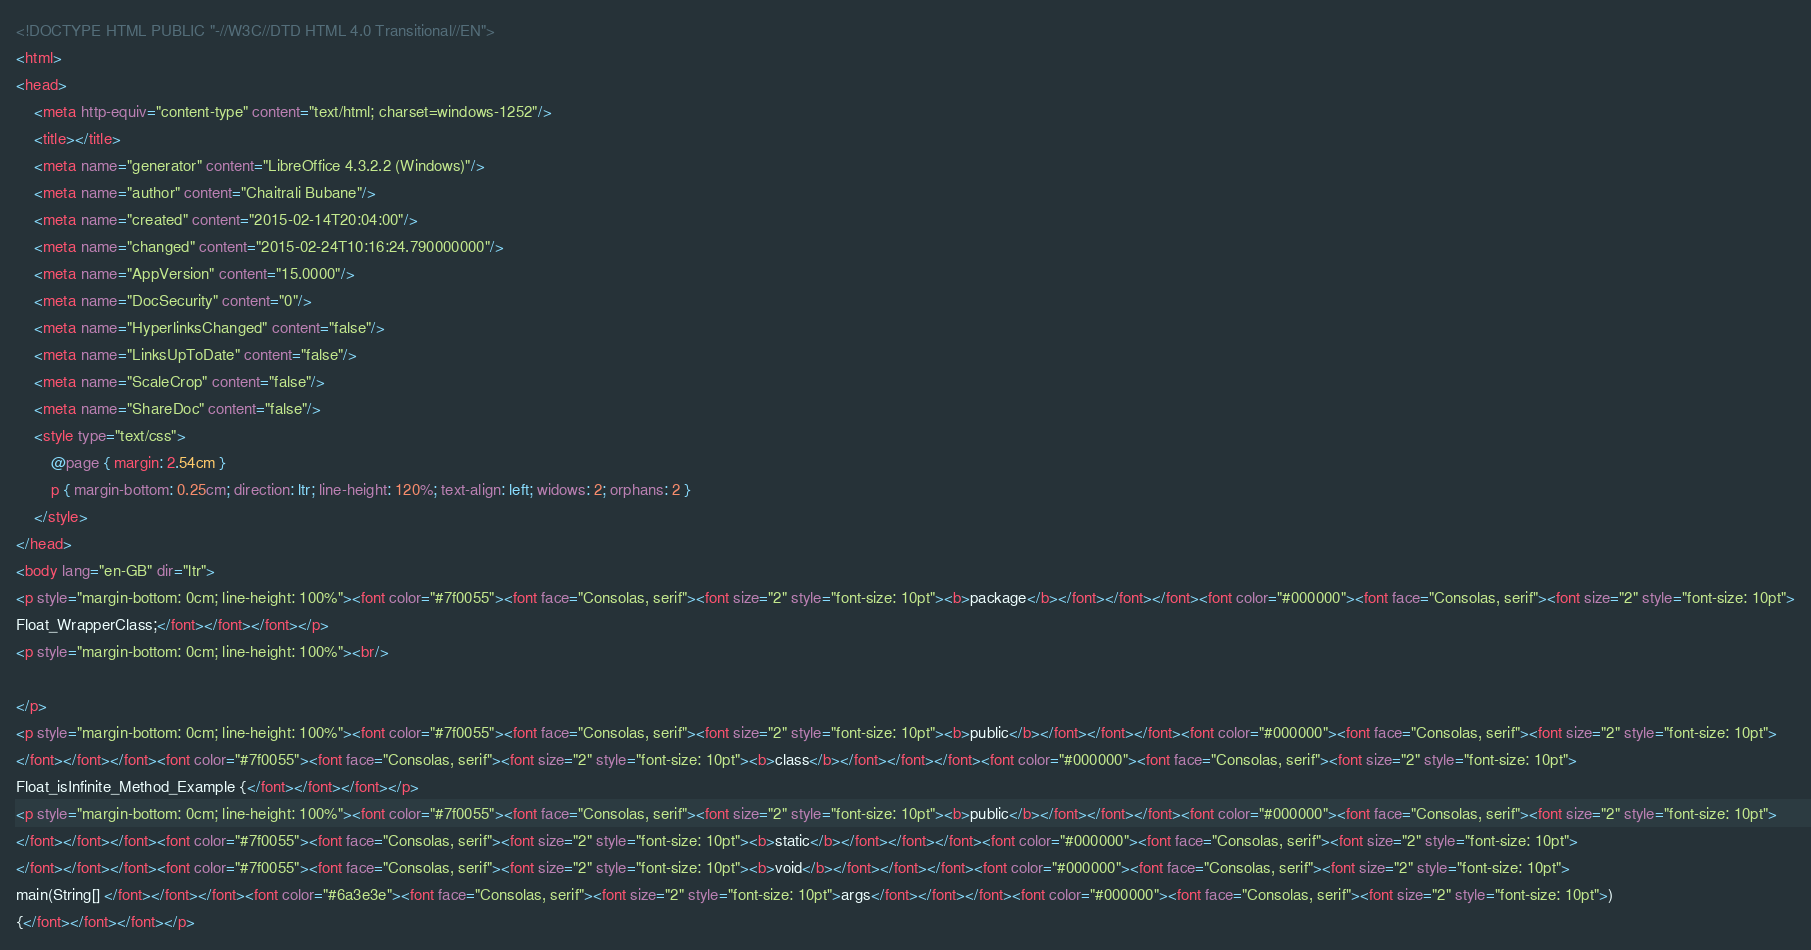<code> <loc_0><loc_0><loc_500><loc_500><_HTML_><!DOCTYPE HTML PUBLIC "-//W3C//DTD HTML 4.0 Transitional//EN">
<html>
<head>
	<meta http-equiv="content-type" content="text/html; charset=windows-1252"/>
	<title></title>
	<meta name="generator" content="LibreOffice 4.3.2.2 (Windows)"/>
	<meta name="author" content="Chaitrali Bubane"/>
	<meta name="created" content="2015-02-14T20:04:00"/>
	<meta name="changed" content="2015-02-24T10:16:24.790000000"/>
	<meta name="AppVersion" content="15.0000"/>
	<meta name="DocSecurity" content="0"/>
	<meta name="HyperlinksChanged" content="false"/>
	<meta name="LinksUpToDate" content="false"/>
	<meta name="ScaleCrop" content="false"/>
	<meta name="ShareDoc" content="false"/>
	<style type="text/css">
		@page { margin: 2.54cm }
		p { margin-bottom: 0.25cm; direction: ltr; line-height: 120%; text-align: left; widows: 2; orphans: 2 }
	</style>
</head>
<body lang="en-GB" dir="ltr">
<p style="margin-bottom: 0cm; line-height: 100%"><font color="#7f0055"><font face="Consolas, serif"><font size="2" style="font-size: 10pt"><b>package</b></font></font></font><font color="#000000"><font face="Consolas, serif"><font size="2" style="font-size: 10pt">
Float_WrapperClass;</font></font></font></p>
<p style="margin-bottom: 0cm; line-height: 100%"><br/>

</p>
<p style="margin-bottom: 0cm; line-height: 100%"><font color="#7f0055"><font face="Consolas, serif"><font size="2" style="font-size: 10pt"><b>public</b></font></font></font><font color="#000000"><font face="Consolas, serif"><font size="2" style="font-size: 10pt">
</font></font></font><font color="#7f0055"><font face="Consolas, serif"><font size="2" style="font-size: 10pt"><b>class</b></font></font></font><font color="#000000"><font face="Consolas, serif"><font size="2" style="font-size: 10pt">
Float_isInfinite_Method_Example {</font></font></font></p>
<p style="margin-bottom: 0cm; line-height: 100%"><font color="#7f0055"><font face="Consolas, serif"><font size="2" style="font-size: 10pt"><b>public</b></font></font></font><font color="#000000"><font face="Consolas, serif"><font size="2" style="font-size: 10pt">
</font></font></font><font color="#7f0055"><font face="Consolas, serif"><font size="2" style="font-size: 10pt"><b>static</b></font></font></font><font color="#000000"><font face="Consolas, serif"><font size="2" style="font-size: 10pt">
</font></font></font><font color="#7f0055"><font face="Consolas, serif"><font size="2" style="font-size: 10pt"><b>void</b></font></font></font><font color="#000000"><font face="Consolas, serif"><font size="2" style="font-size: 10pt">
main(String[] </font></font></font><font color="#6a3e3e"><font face="Consolas, serif"><font size="2" style="font-size: 10pt">args</font></font></font><font color="#000000"><font face="Consolas, serif"><font size="2" style="font-size: 10pt">)
{</font></font></font></p></code> 